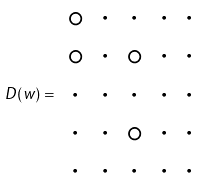Convert formula to latex. <formula><loc_0><loc_0><loc_500><loc_500>D ( w ) = \begin{array} { c c c c c } \circ & \cdot & \cdot & \cdot & \cdot \\ \circ & \cdot & \circ & \cdot & \cdot \\ \cdot & \cdot & \cdot & \cdot & \cdot \\ \cdot & \cdot & \circ & \cdot & \cdot \\ \cdot & \cdot & \cdot & \cdot & \cdot \\ \end{array}</formula> 